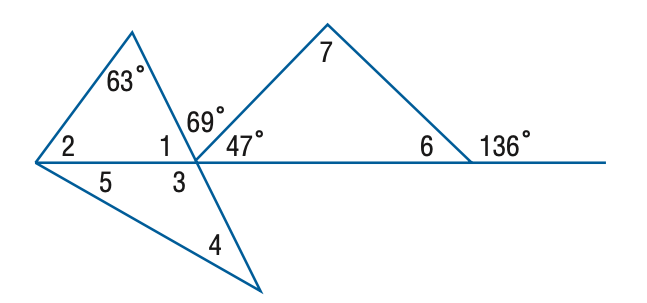Answer the mathemtical geometry problem and directly provide the correct option letter.
Question: Find the measure of \angle 6 if m \angle 4 = m \angle 5.
Choices: A: 44 B: 47 C: 53 D: 64 A 